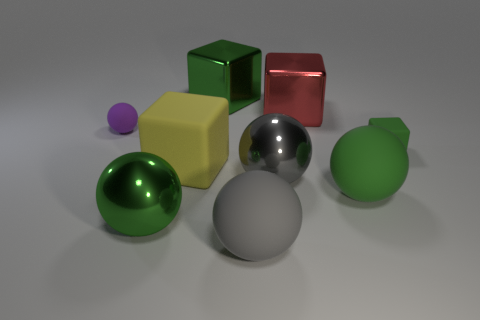Is there any other thing that has the same color as the small rubber block?
Keep it short and to the point. Yes. Are the green cube in front of the purple matte object and the green object on the left side of the yellow rubber thing made of the same material?
Provide a short and direct response. No. What is the big cube that is left of the large red block and on the right side of the yellow rubber block made of?
Ensure brevity in your answer.  Metal. Does the purple object have the same shape as the large green object to the right of the big green shiny cube?
Your response must be concise. Yes. What is the green thing that is left of the big green block behind the big green thing to the right of the gray matte object made of?
Ensure brevity in your answer.  Metal. How many other things are there of the same size as the yellow matte object?
Provide a short and direct response. 6. There is a yellow matte object that is on the right side of the small purple ball behind the big yellow rubber block; how many gray balls are behind it?
Make the answer very short. 0. There is a green thing behind the rubber thing left of the big yellow rubber thing; what is it made of?
Provide a short and direct response. Metal. Are there any purple rubber objects of the same shape as the big gray rubber thing?
Your answer should be very brief. Yes. What is the color of the rubber cube that is the same size as the green rubber sphere?
Give a very brief answer. Yellow. 